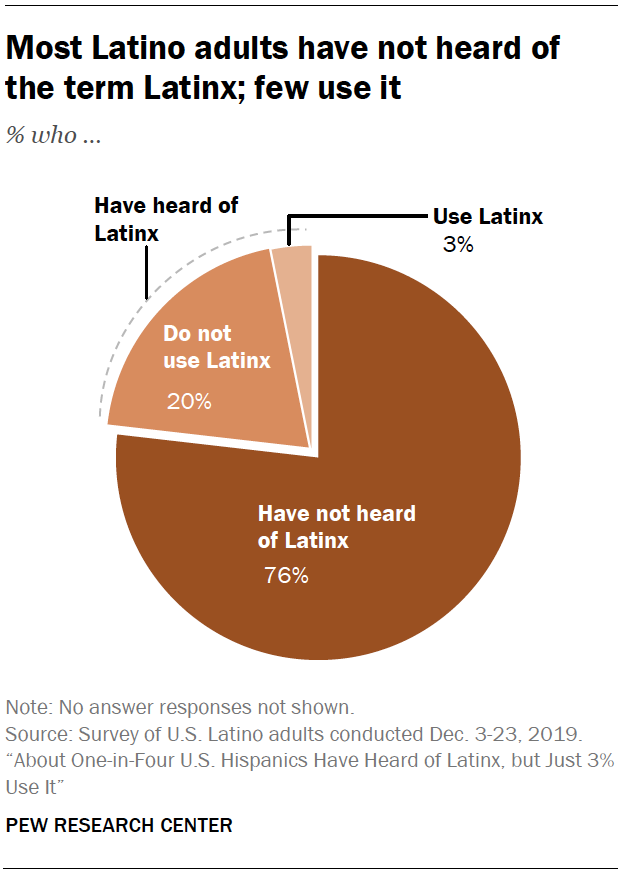Specify some key components in this picture. According to a recent survey, only 20% of Latino adults do not use the term Latinx to describe themselves. 